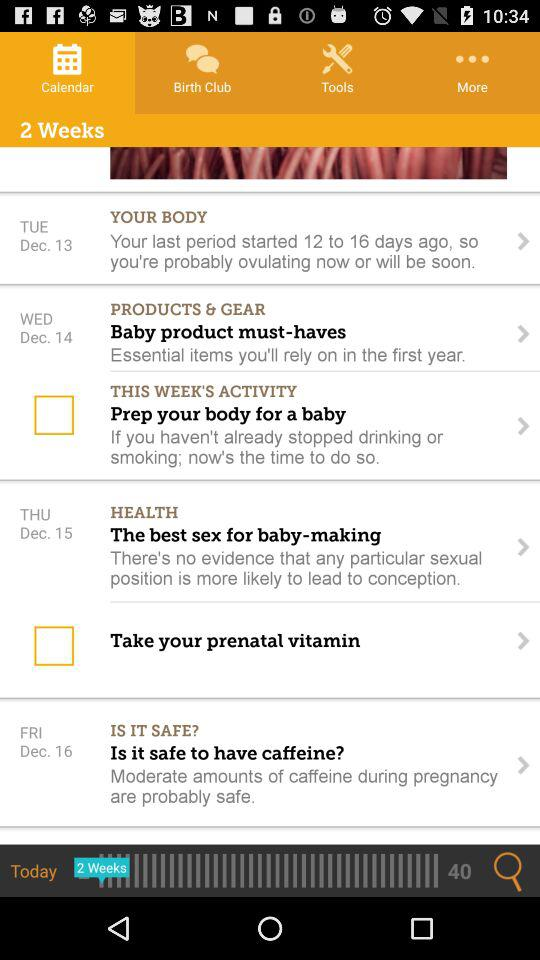Which day is December 15th? The day is Thursday. 